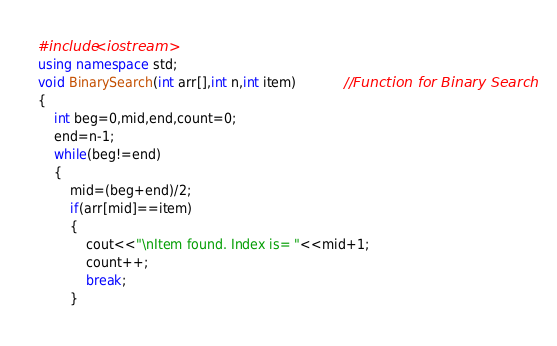Convert code to text. <code><loc_0><loc_0><loc_500><loc_500><_C++_>#include<iostream>
using namespace std;
void BinarySearch(int arr[],int n,int item)			//Function for Binary Search
{
	int beg=0,mid,end,count=0;
	end=n-1;
	while(beg!=end)
	{
		mid=(beg+end)/2;
		if(arr[mid]==item)
		{
			cout<<"\nItem found. Index is= "<<mid+1;
			count++;
			break;
		}</code> 